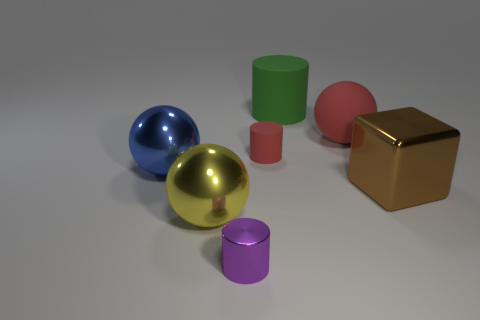Is there any other thing that is the same color as the small shiny cylinder?
Provide a short and direct response. No. Does the sphere behind the red cylinder have the same material as the large green cylinder?
Ensure brevity in your answer.  Yes. How many big objects are both behind the brown shiny cube and to the left of the tiny rubber cylinder?
Offer a very short reply. 1. How big is the sphere that is on the left side of the ball that is in front of the blue object?
Your response must be concise. Large. Is there anything else that has the same material as the small purple cylinder?
Keep it short and to the point. Yes. Are there more big matte things than large red spheres?
Your response must be concise. Yes. Is the color of the cylinder in front of the big blue metal sphere the same as the big sphere behind the red cylinder?
Offer a very short reply. No. There is a red matte object that is in front of the red rubber ball; is there a tiny red rubber thing on the left side of it?
Give a very brief answer. No. Is the number of objects that are right of the big brown metallic cube less than the number of red matte cylinders behind the red rubber cylinder?
Your answer should be very brief. No. Is the tiny object left of the red cylinder made of the same material as the tiny cylinder behind the tiny purple shiny cylinder?
Keep it short and to the point. No. 